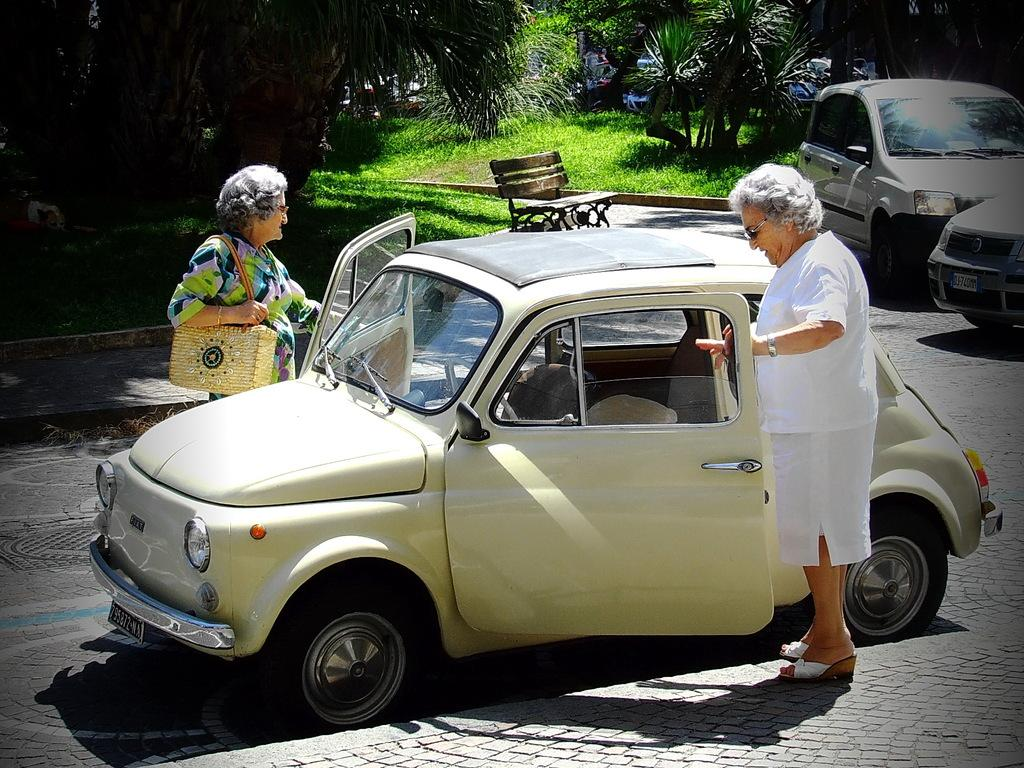How many people are in the image? There are two persons standing in the image. What can be seen on the road in the image? Cars are visible on the road in the image. What type of natural elements are present in the image? Trees are present in the image. Can you describe the attire of one of the persons? One person is wearing a bag. What is the price of the fiction book being read by one of the persons in the image? There is no indication of a book, let alone a fiction book, being read by one of the persons in the image. 